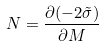<formula> <loc_0><loc_0><loc_500><loc_500>N = \frac { \partial ( - 2 \tilde { \sigma } ) } { \partial M }</formula> 